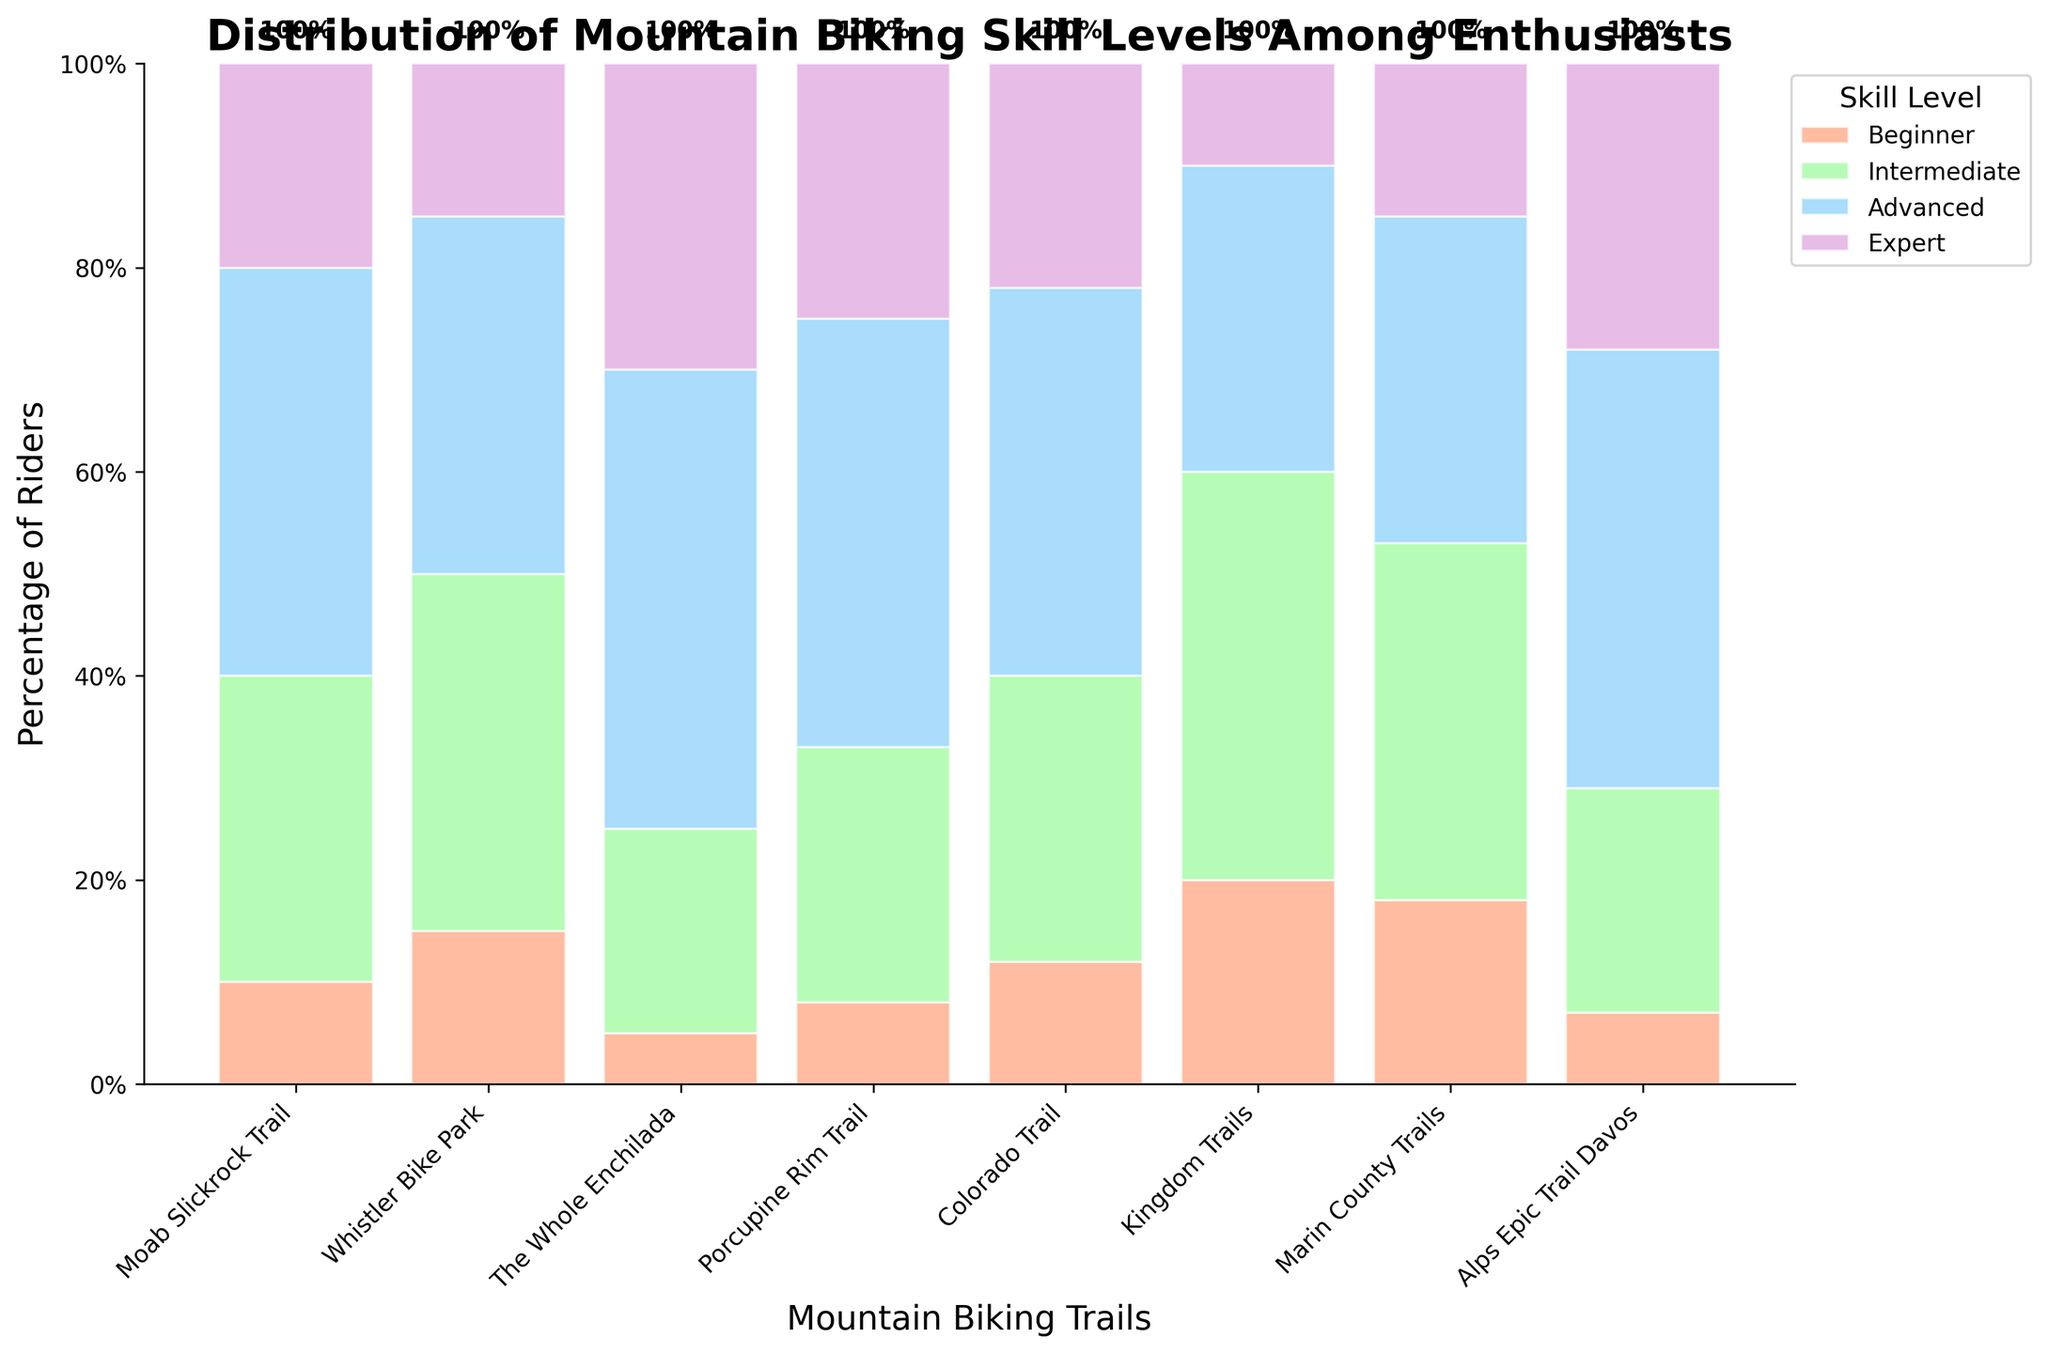What's the title of the figure? The title is usually displayed at the top of the figure, typically in a larger or bold font.
Answer: Distribution of Mountain Biking Skill Levels Among Enthusiasts What skill level is the most represented on the Moab Slickrock Trail? Looking at the height of the bars for Moab Slickrock Trail, the tallest bar represents the skill level with the highest percentage. On the figure, the 'Advanced' skill level has the tallest bar.
Answer: Advanced How many trails show exactly 25% or more Expert riders? To determine this, look at the height of the bars corresponding to the Expert skill level and count how many exceed the 25% mark. These trails are The Whole Enchilada, Porcupine Rim Trail, and Alps Epic Trail Davos.
Answer: 3 Which trail has the highest percentage of Beginner riders? Identify the trail with the tallest bar for the 'Beginner' section. In the chart, the Kingdom Trails bar is the tallest for this skill level.
Answer: Kingdom Trails On which trail are Intermediate riders the predominant group? Determine this by identifying the trail where the Intermediate bar is the tallest in comparison to the other skill levels. The Kingdom Trails have the tallest Intermediate bar.
Answer: Kingdom Trails Which trail has the smallest percentage difference between Advanced and Expert riders? Calculate the differences between Advanced and Expert riders for each trail and identify the smallest one. The smallest difference is seen in the Whistler Bike Park with only 20% Advanced and 15% Expert. The difference is 5%.
Answer: Whistler Bike Park What's the average percentage of Advanced riders across all trails? To find the average, add up the percentage values for Advanced riders (40, 35, 45, 42, 38, 30, 32, 43) and divide by the number of trails (8). The calculation is (40+35+45+42+38+30+32+43)/8 = 38.13.
Answer: 38.13 Which trail has the most balanced distribution of all skill levels? The most balanced trail will have bars of similar heights for all skill levels. In the figure, Whistler Bike Park appears most balanced as the bars for all skill levels are relatively close in height.
Answer: Whistler Bike Park 